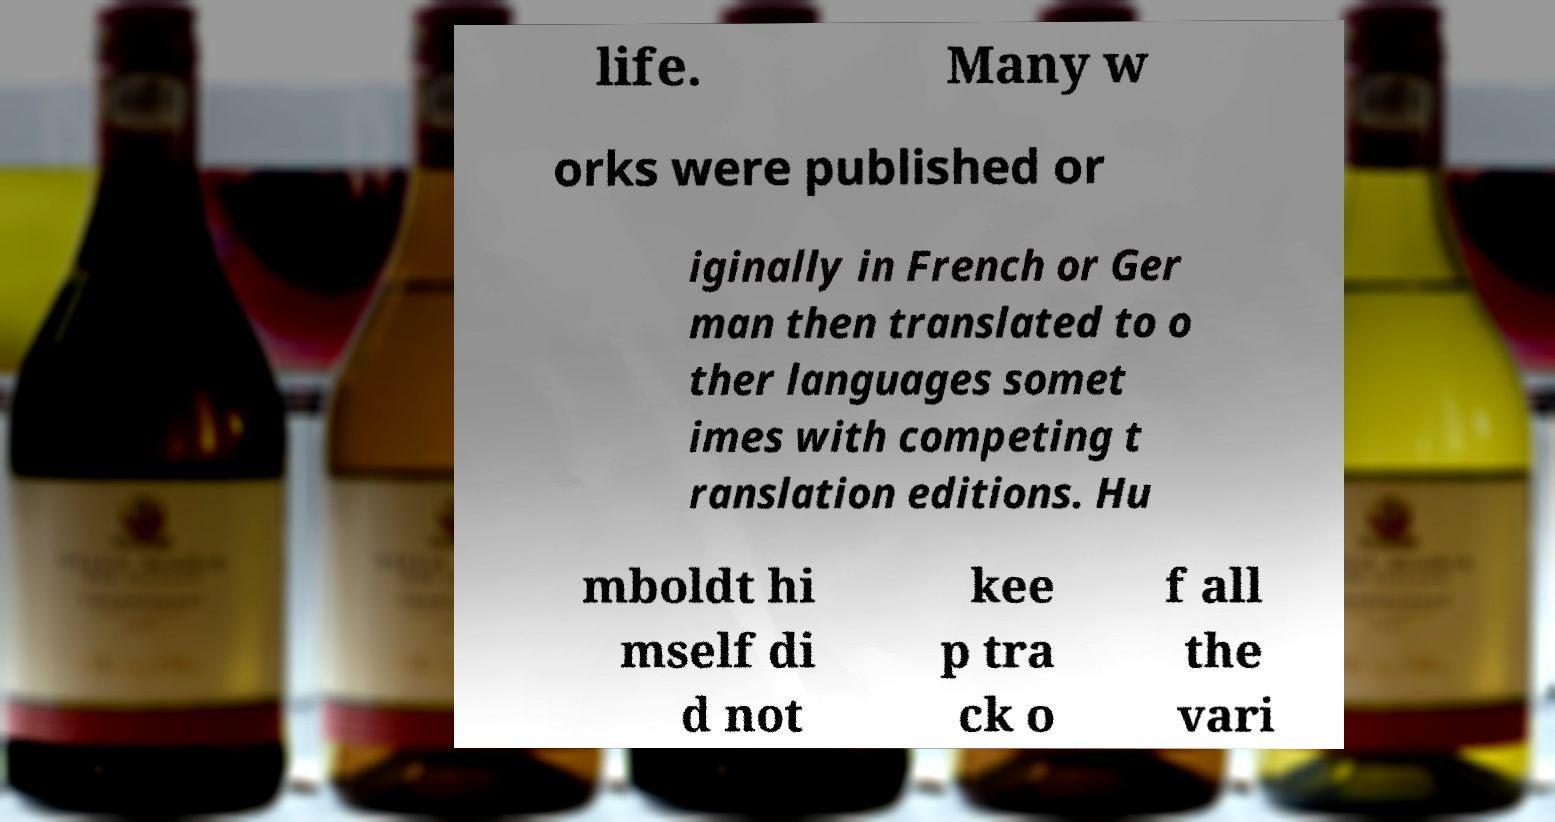There's text embedded in this image that I need extracted. Can you transcribe it verbatim? life. Many w orks were published or iginally in French or Ger man then translated to o ther languages somet imes with competing t ranslation editions. Hu mboldt hi mself di d not kee p tra ck o f all the vari 